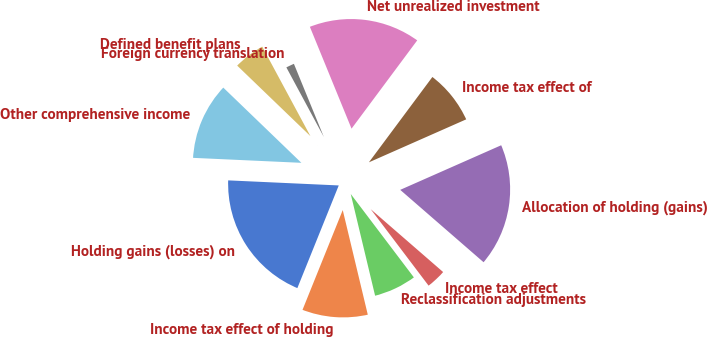<chart> <loc_0><loc_0><loc_500><loc_500><pie_chart><fcel>Holding gains (losses) on<fcel>Income tax effect of holding<fcel>Reclassification adjustments<fcel>Income tax effect<fcel>Allocation of holding (gains)<fcel>Income tax effect of<fcel>Net unrealized investment<fcel>Foreign currency translation<fcel>Defined benefit plans<fcel>Other comprehensive income<nl><fcel>19.63%<fcel>9.84%<fcel>6.57%<fcel>3.31%<fcel>18.0%<fcel>8.2%<fcel>16.36%<fcel>1.68%<fcel>4.94%<fcel>11.47%<nl></chart> 